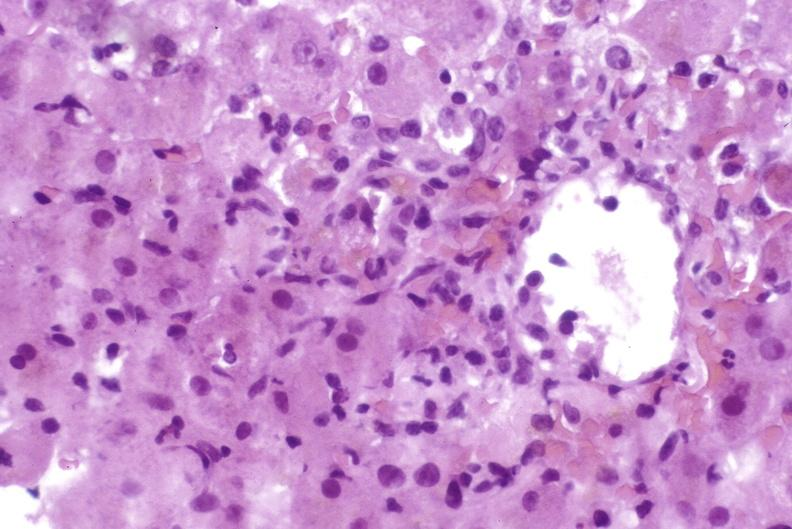does this image show moderate acute rejection?
Answer the question using a single word or phrase. Yes 